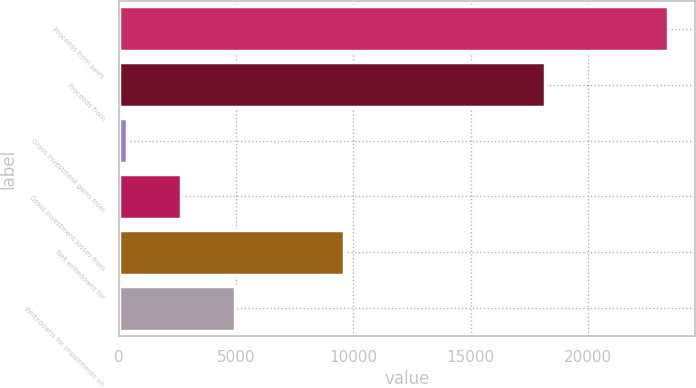Convert chart. <chart><loc_0><loc_0><loc_500><loc_500><bar_chart><fcel>Proceeds from sales<fcel>Proceeds from<fcel>Gross investment gains from<fcel>Gross investment losses from<fcel>Net writedowns for<fcel>Writedowns for impairments on<nl><fcel>23390<fcel>18182<fcel>378<fcel>2679.2<fcel>9582.8<fcel>4980.4<nl></chart> 